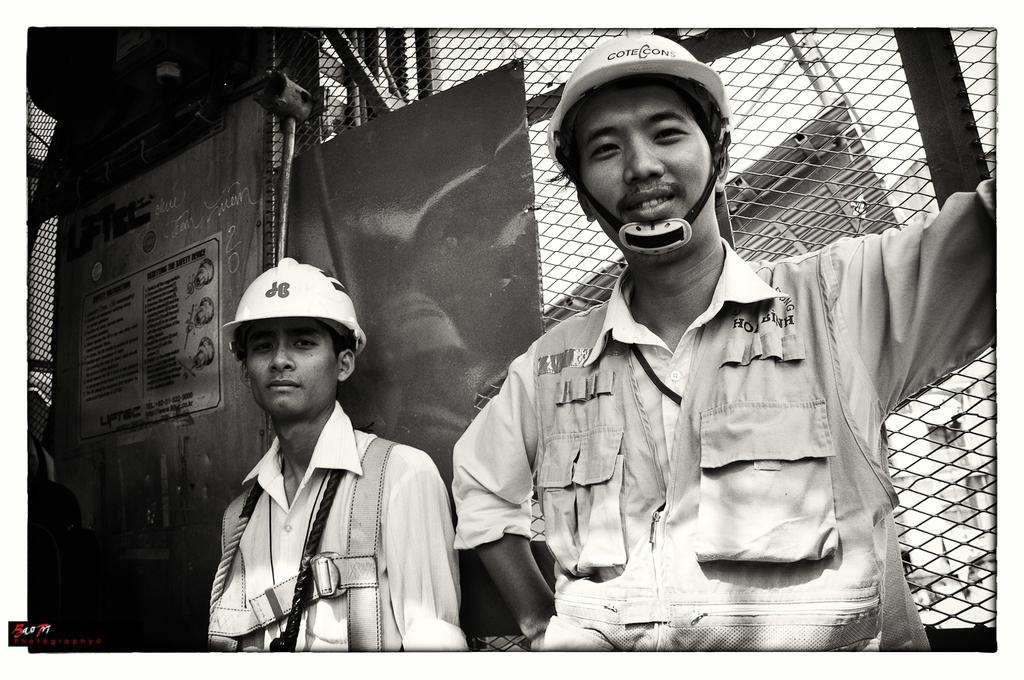How many people are in the image? There are two men in the image. What are the men wearing on their heads? The men are wearing helmets. What can be seen in the background of the image? There is a fence and a metal door with a sticker on it in the background of the image. What type of boot is the man wearing on his left foot in the image? There is no boot visible on either man's foot in the image. Can you describe the spot where the men are standing in the image? The provided facts do not give information about the specific spot where the men are standing in the image. 